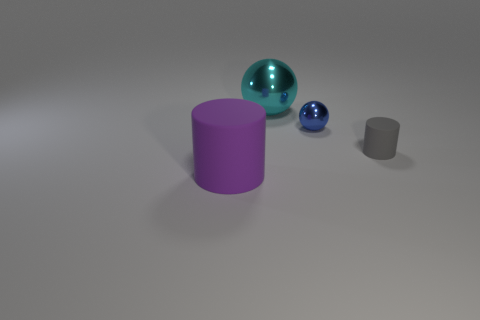There is a big thing that is behind the gray rubber cylinder; is its color the same as the large thing in front of the tiny blue metallic thing?
Your answer should be compact. No. Does the purple rubber thing have the same shape as the big cyan shiny object?
Give a very brief answer. No. Are there any other things that are the same shape as the blue metallic thing?
Provide a short and direct response. Yes. Is the material of the tiny gray object that is right of the big cyan sphere the same as the big cyan object?
Keep it short and to the point. No. There is a thing that is in front of the tiny blue sphere and left of the small rubber thing; what shape is it?
Your answer should be very brief. Cylinder. Is there a blue thing that is to the right of the matte object on the right side of the cyan object?
Ensure brevity in your answer.  No. How many other things are there of the same material as the small gray thing?
Make the answer very short. 1. Does the large thing in front of the large cyan metallic sphere have the same shape as the small object that is behind the gray cylinder?
Provide a succinct answer. No. Does the big cylinder have the same material as the tiny blue object?
Your answer should be very brief. No. What size is the matte object on the right side of the matte thing that is in front of the rubber cylinder that is behind the large purple cylinder?
Your answer should be compact. Small. 